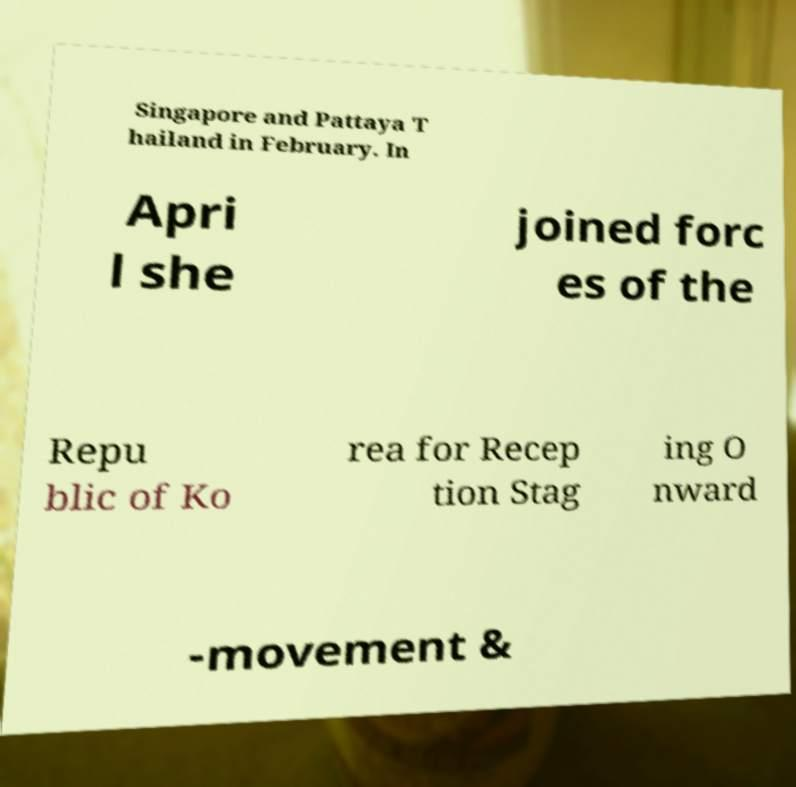There's text embedded in this image that I need extracted. Can you transcribe it verbatim? Singapore and Pattaya T hailand in February. In Apri l she joined forc es of the Repu blic of Ko rea for Recep tion Stag ing O nward -movement & 